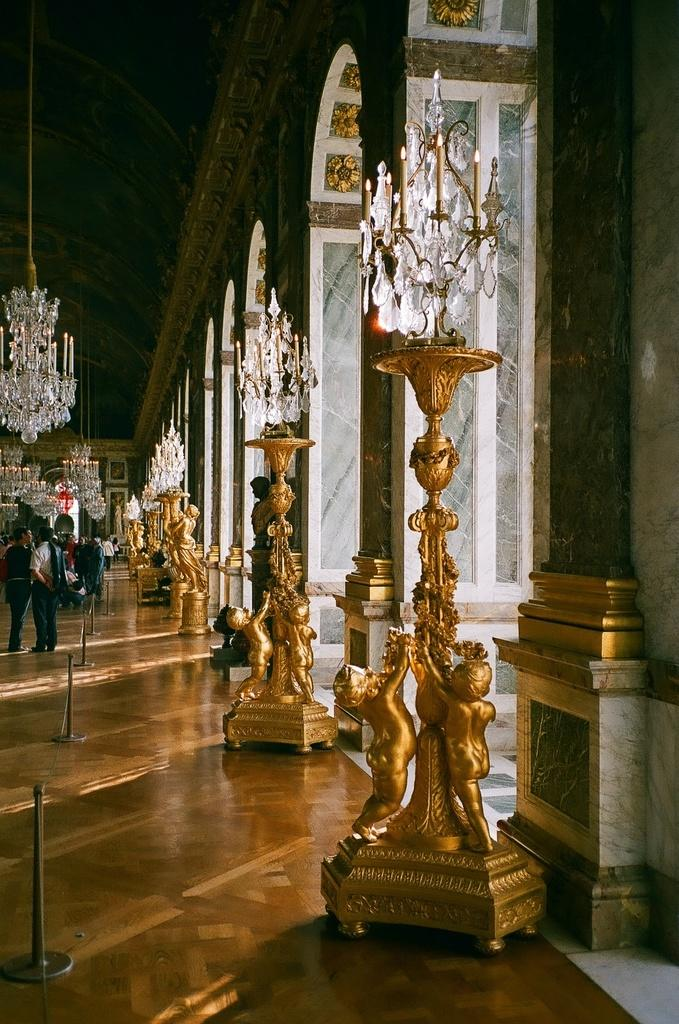What type of lighting fixtures are present in the image? There are floor lamp light chandeliers in the image. Where are the floor lamp light chandeliers located? The floor lamp light chandeliers are placed on the ground. What is the scientific reaction taking place in the image? There is no scientific reaction present in the image; it features floor lamp light chandeliers placed on the ground. 